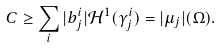Convert formula to latex. <formula><loc_0><loc_0><loc_500><loc_500>C \geq \sum _ { i } | b _ { j } ^ { i } | \mathcal { H } ^ { 1 } ( \gamma _ { j } ^ { i } ) = | \mu _ { j } | ( \Omega ) .</formula> 